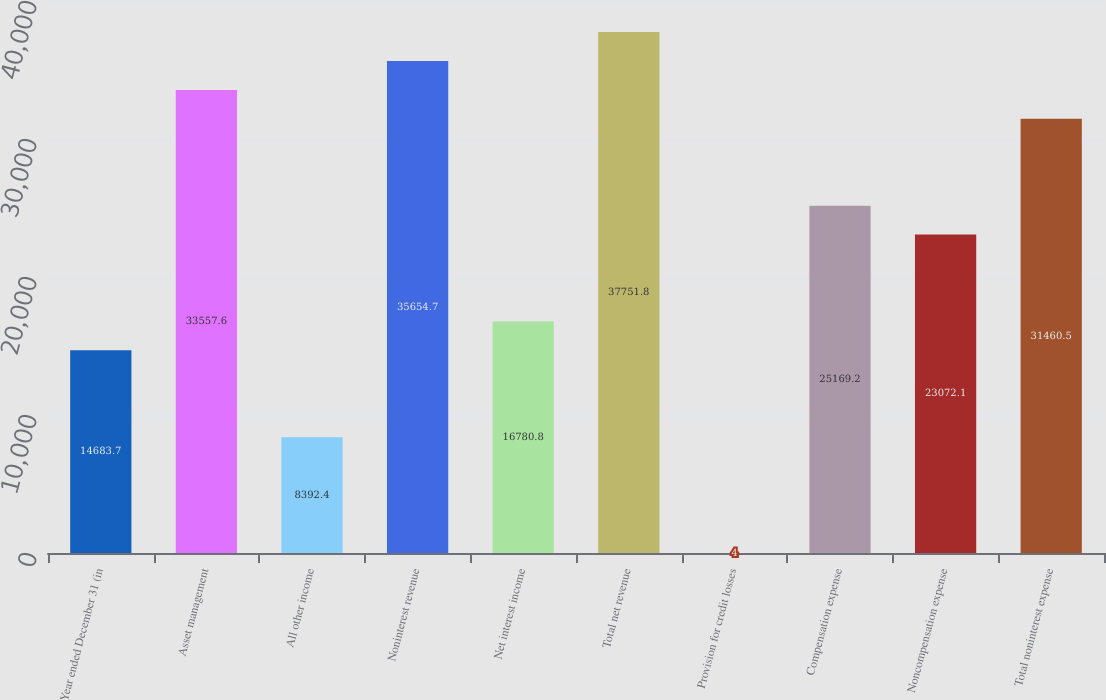Convert chart to OTSL. <chart><loc_0><loc_0><loc_500><loc_500><bar_chart><fcel>Year ended December 31 (in<fcel>Asset management<fcel>All other income<fcel>Noninterest revenue<fcel>Net interest income<fcel>Total net revenue<fcel>Provision for credit losses<fcel>Compensation expense<fcel>Noncompensation expense<fcel>Total noninterest expense<nl><fcel>14683.7<fcel>33557.6<fcel>8392.4<fcel>35654.7<fcel>16780.8<fcel>37751.8<fcel>4<fcel>25169.2<fcel>23072.1<fcel>31460.5<nl></chart> 